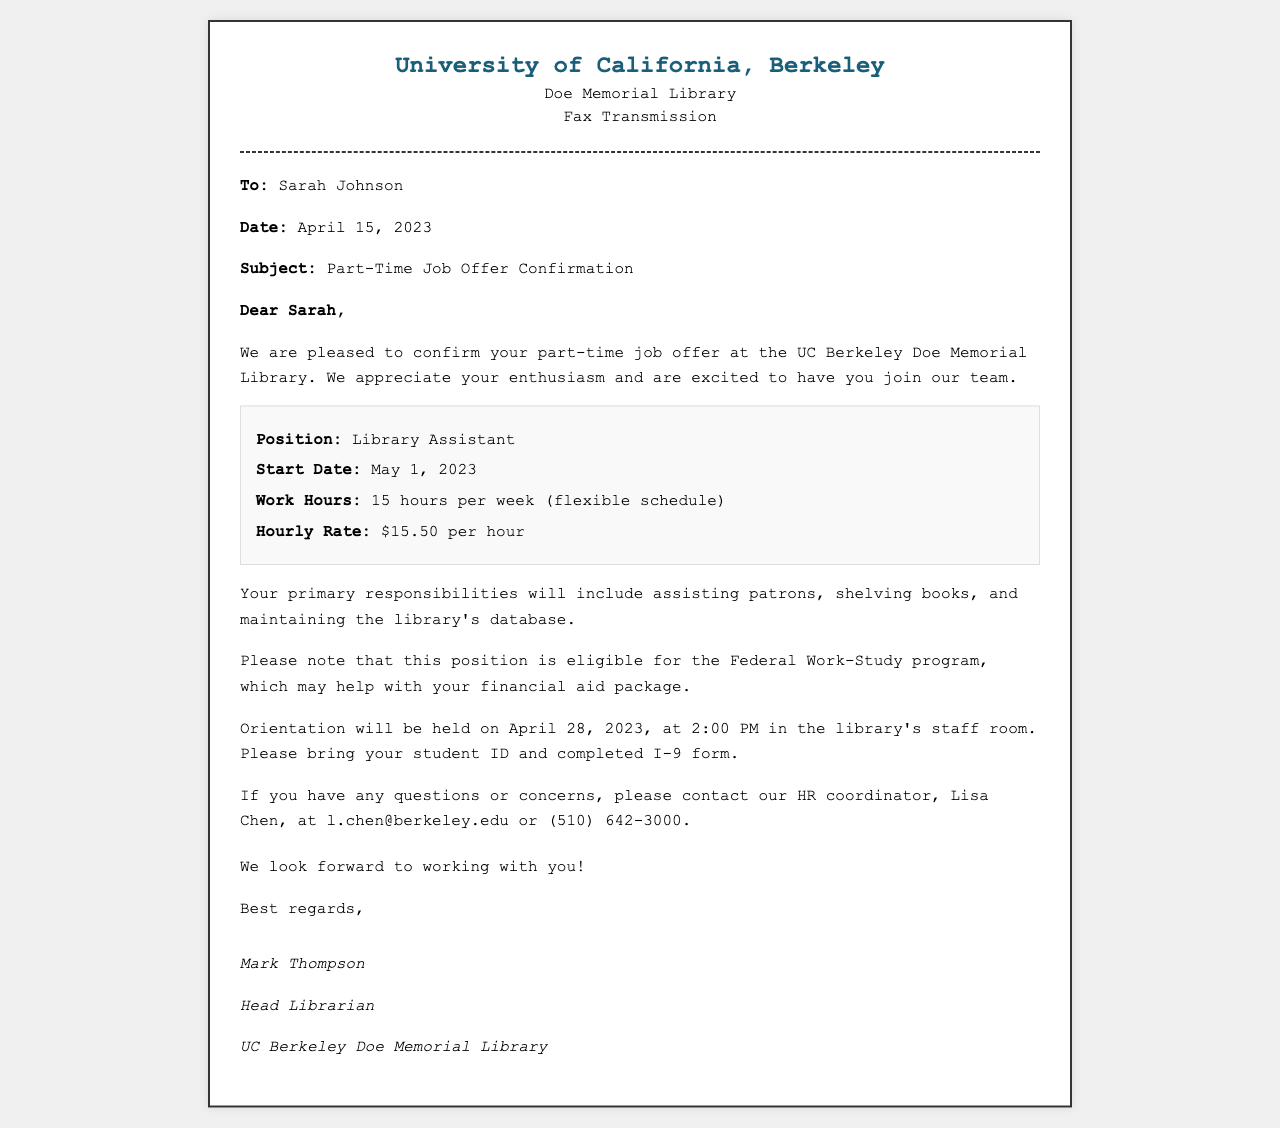what is the position offered? The position offered to Sarah is specified in the job details section of the document.
Answer: Library Assistant what is the hourly rate for the position? The document includes the hourly wage for the job offer within the job details.
Answer: $15.50 per hour when does the job start? The start date of the job is mentioned within the body of the fax.
Answer: May 1, 2023 how many hours per week will Sarah work? The document indicates the number of hours per week that the employee is expected to work in the job details section.
Answer: 15 hours per week who is the contact person for any questions? The HR contact's name is mentioned towards the end of the document, specifying who to reach out to if there are inquiries.
Answer: Lisa Chen what is the date of orientation? The orientation date is stated in the document, where the schedule is laid out for the new employee.
Answer: April 28, 2023 where will the orientation take place? The location of the orientation is outlined in the body text of the fax.
Answer: library's staff room does this position involve Federal Work-Study eligibility? The document describes the relationship of the job with financial aid opportunities.
Answer: Yes how should Sarah prepare for orientation? The document provides specific instructions on what to bring to the orientation session.
Answer: student ID and completed I-9 form 